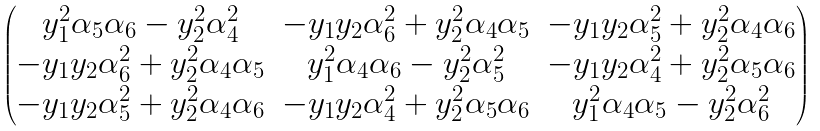Convert formula to latex. <formula><loc_0><loc_0><loc_500><loc_500>\begin{pmatrix} y _ { 1 } ^ { 2 } \alpha _ { 5 } \alpha _ { 6 } - y _ { 2 } ^ { 2 } \alpha _ { 4 } ^ { 2 } & - y _ { 1 } y _ { 2 } \alpha _ { 6 } ^ { 2 } + y _ { 2 } ^ { 2 } \alpha _ { 4 } \alpha _ { 5 } & - y _ { 1 } y _ { 2 } \alpha _ { 5 } ^ { 2 } + y _ { 2 } ^ { 2 } \alpha _ { 4 } \alpha _ { 6 } \\ - y _ { 1 } y _ { 2 } \alpha _ { 6 } ^ { 2 } + y _ { 2 } ^ { 2 } \alpha _ { 4 } \alpha _ { 5 } & y _ { 1 } ^ { 2 } \alpha _ { 4 } \alpha _ { 6 } - y _ { 2 } ^ { 2 } \alpha _ { 5 } ^ { 2 } & - y _ { 1 } y _ { 2 } \alpha _ { 4 } ^ { 2 } + y _ { 2 } ^ { 2 } \alpha _ { 5 } \alpha _ { 6 } \\ - y _ { 1 } y _ { 2 } \alpha _ { 5 } ^ { 2 } + y _ { 2 } ^ { 2 } \alpha _ { 4 } \alpha _ { 6 } & - y _ { 1 } y _ { 2 } \alpha _ { 4 } ^ { 2 } + y _ { 2 } ^ { 2 } \alpha _ { 5 } \alpha _ { 6 } & y _ { 1 } ^ { 2 } \alpha _ { 4 } \alpha _ { 5 } - y _ { 2 } ^ { 2 } \alpha _ { 6 } ^ { 2 } \\ \end{pmatrix}</formula> 